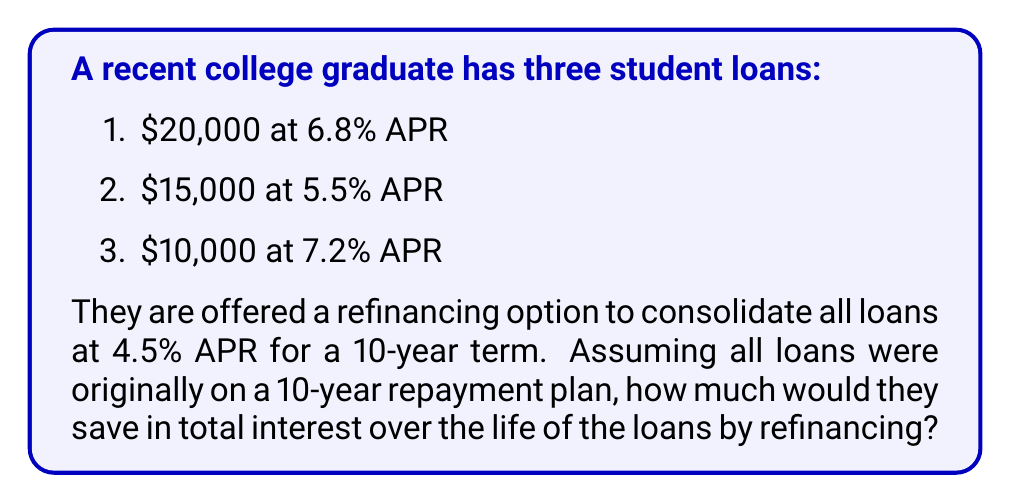Solve this math problem. Let's approach this step-by-step:

1. Calculate the monthly payments and total interest for each original loan:

   For a loan with principal $P$, annual interest rate $r$, and $n$ monthly payments, the monthly payment $M$ is given by:

   $$M = P \cdot \frac{r/12 \cdot (1 + r/12)^n}{(1 + r/12)^n - 1}$$

   a) For the $20,000 loan at 6.8% APR:
      $$M_1 = 20000 \cdot \frac{0.068/12 \cdot (1 + 0.068/12)^{120}}{(1 + 0.068/12)^{120} - 1} = $230.16$$
      Total paid = $230.16 \cdot 120 = $27,619.20
      Total interest = $27,619.20 - $20,000 = $7,619.20

   b) For the $15,000 loan at 5.5% APR:
      $$M_2 = 15000 \cdot \frac{0.055/12 \cdot (1 + 0.055/12)^{120}}{(1 + 0.055/12)^{120} - 1} = $162.87$$
      Total paid = $162.87 \cdot 120 = $19,544.40
      Total interest = $19,544.40 - $15,000 = $4,544.40

   c) For the $10,000 loan at 7.2% APR:
      $$M_3 = 10000 \cdot \frac{0.072/12 \cdot (1 + 0.072/12)^{120}}{(1 + 0.072/12)^{120} - 1} = $116.83$$
      Total paid = $116.83 \cdot 120 = $14,019.60
      Total interest = $14,019.60 - $10,000 = $4,019.60

2. Calculate the total interest for all original loans:
   $7,619.20 + $4,544.40 + $4,019.60 = $16,183.20

3. Calculate the monthly payment and total interest for the refinanced loan:
   Total principal = $20,000 + $15,000 + $10,000 = $45,000

   $$M_{\text{refinanced}} = 45000 \cdot \frac{0.045/12 \cdot (1 + 0.045/12)^{120}}{(1 + 0.045/12)^{120} - 1} = $466.08$$

   Total paid = $466.08 \cdot 120 = $55,929.60
   Total interest = $55,929.60 - $45,000 = $10,929.60

4. Calculate the savings:
   Savings = Original total interest - Refinanced total interest
   Savings = $16,183.20 - $10,929.60 = $5,253.60
Answer: $5,253.60 